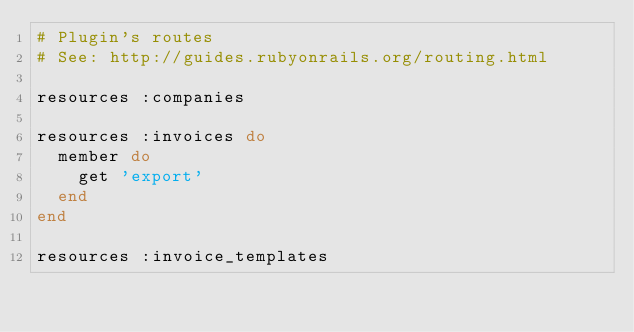Convert code to text. <code><loc_0><loc_0><loc_500><loc_500><_Ruby_># Plugin's routes
# See: http://guides.rubyonrails.org/routing.html

resources :companies

resources :invoices do
  member do
    get 'export'
  end
end

resources :invoice_templates
</code> 